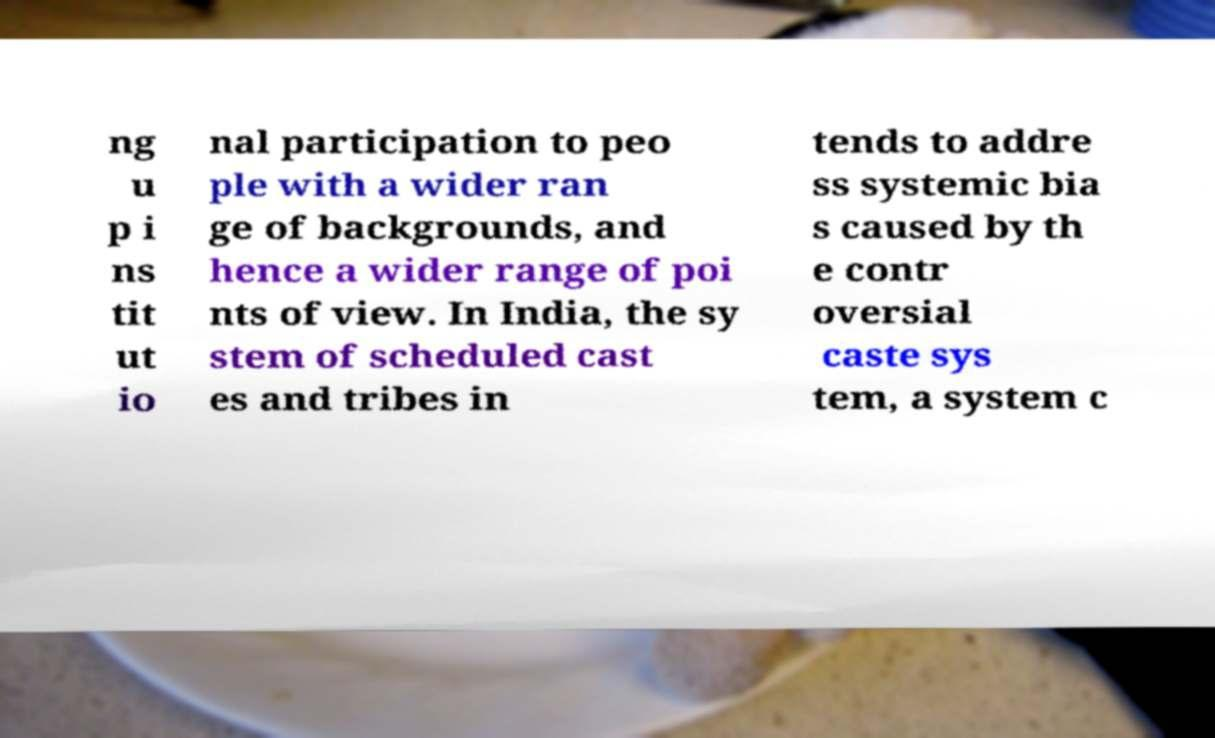Please identify and transcribe the text found in this image. ng u p i ns tit ut io nal participation to peo ple with a wider ran ge of backgrounds, and hence a wider range of poi nts of view. In India, the sy stem of scheduled cast es and tribes in tends to addre ss systemic bia s caused by th e contr oversial caste sys tem, a system c 